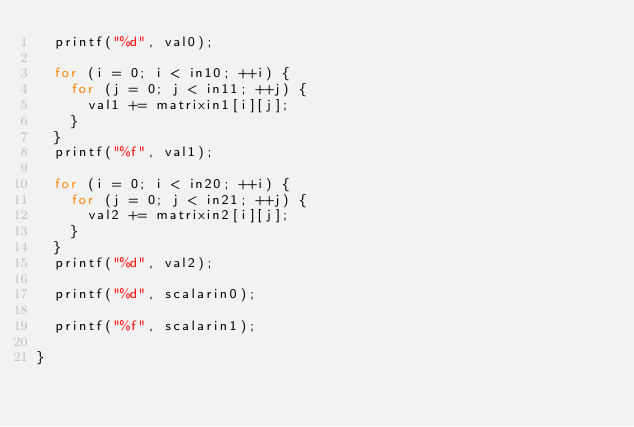Convert code to text. <code><loc_0><loc_0><loc_500><loc_500><_C_>  printf("%d", val0);

  for (i = 0; i < in10; ++i) {
    for (j = 0; j < in11; ++j) {
      val1 += matrixin1[i][j];
    }
  }
  printf("%f", val1);

  for (i = 0; i < in20; ++i) {
    for (j = 0; j < in21; ++j) {
      val2 += matrixin2[i][j];
    }
  }
  printf("%d", val2);

  printf("%d", scalarin0);

  printf("%f", scalarin1);

}
</code> 